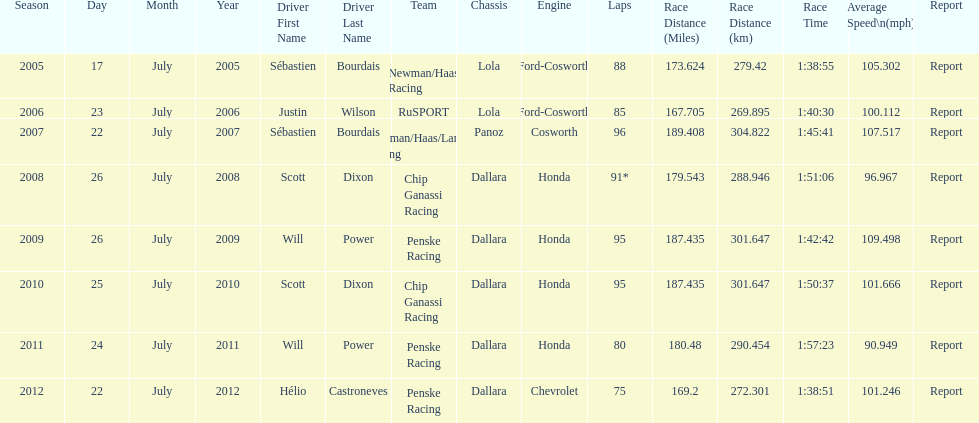Which team won the champ car world series the year before rusport? Newman/Haas Racing. 